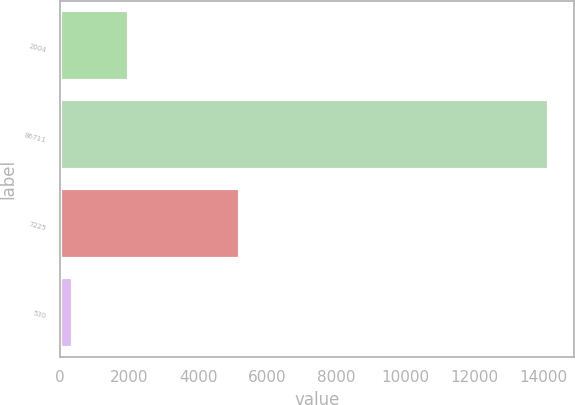<chart> <loc_0><loc_0><loc_500><loc_500><bar_chart><fcel>2004<fcel>86711<fcel>7225<fcel>530<nl><fcel>2003<fcel>14164<fcel>5204<fcel>389<nl></chart> 